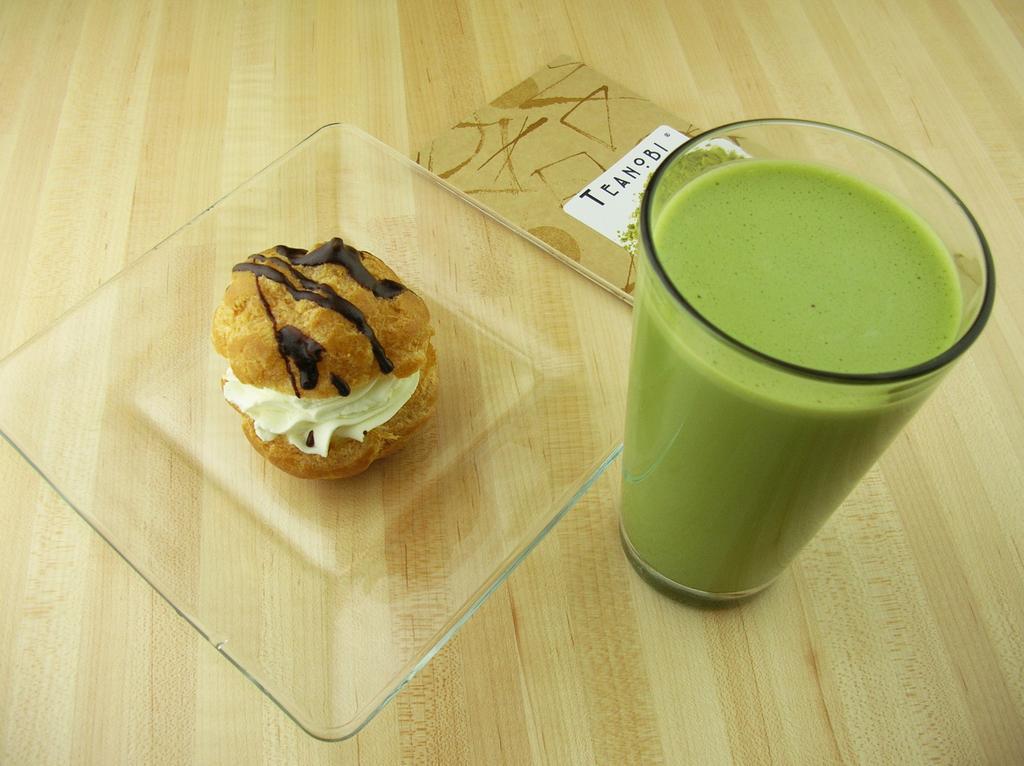Please provide a concise description of this image. There is a glass plate and glass on a wooden surface. On the wooden surface there is a label. Inside the glass there is a green color drink. On the plate there is a snack with white cream and chocolate. 